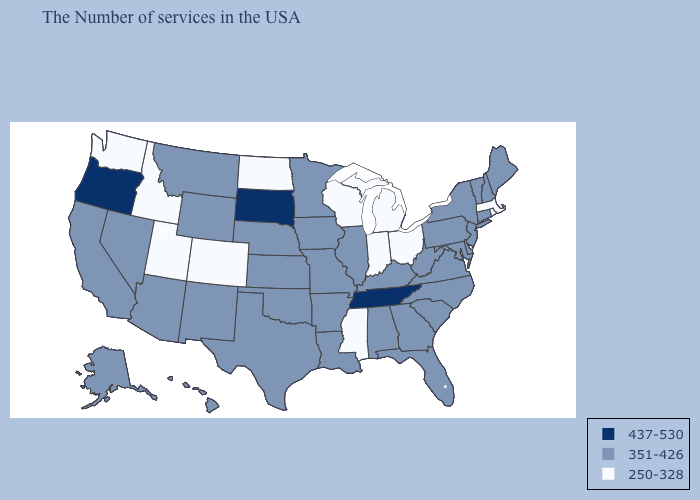Is the legend a continuous bar?
Quick response, please. No. What is the lowest value in states that border Texas?
Short answer required. 351-426. Does Mississippi have the same value as Ohio?
Short answer required. Yes. What is the lowest value in the South?
Give a very brief answer. 250-328. Name the states that have a value in the range 351-426?
Be succinct. Maine, New Hampshire, Vermont, Connecticut, New York, New Jersey, Delaware, Maryland, Pennsylvania, Virginia, North Carolina, South Carolina, West Virginia, Florida, Georgia, Kentucky, Alabama, Illinois, Louisiana, Missouri, Arkansas, Minnesota, Iowa, Kansas, Nebraska, Oklahoma, Texas, Wyoming, New Mexico, Montana, Arizona, Nevada, California, Alaska, Hawaii. Does Utah have the highest value in the USA?
Short answer required. No. Does Tennessee have the highest value in the South?
Keep it brief. Yes. What is the value of Oklahoma?
Write a very short answer. 351-426. What is the lowest value in states that border North Carolina?
Concise answer only. 351-426. Name the states that have a value in the range 437-530?
Be succinct. Tennessee, South Dakota, Oregon. Does the map have missing data?
Write a very short answer. No. Which states have the lowest value in the South?
Write a very short answer. Mississippi. What is the lowest value in the MidWest?
Concise answer only. 250-328. Name the states that have a value in the range 250-328?
Short answer required. Massachusetts, Rhode Island, Ohio, Michigan, Indiana, Wisconsin, Mississippi, North Dakota, Colorado, Utah, Idaho, Washington. Does Michigan have the lowest value in the USA?
Answer briefly. Yes. 